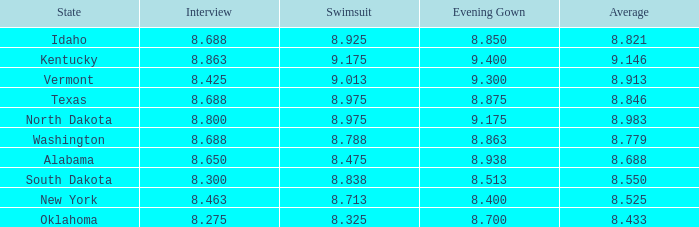For contestants from texas with evening gowns bigger than size 8.875, what is the highest average score? None. 